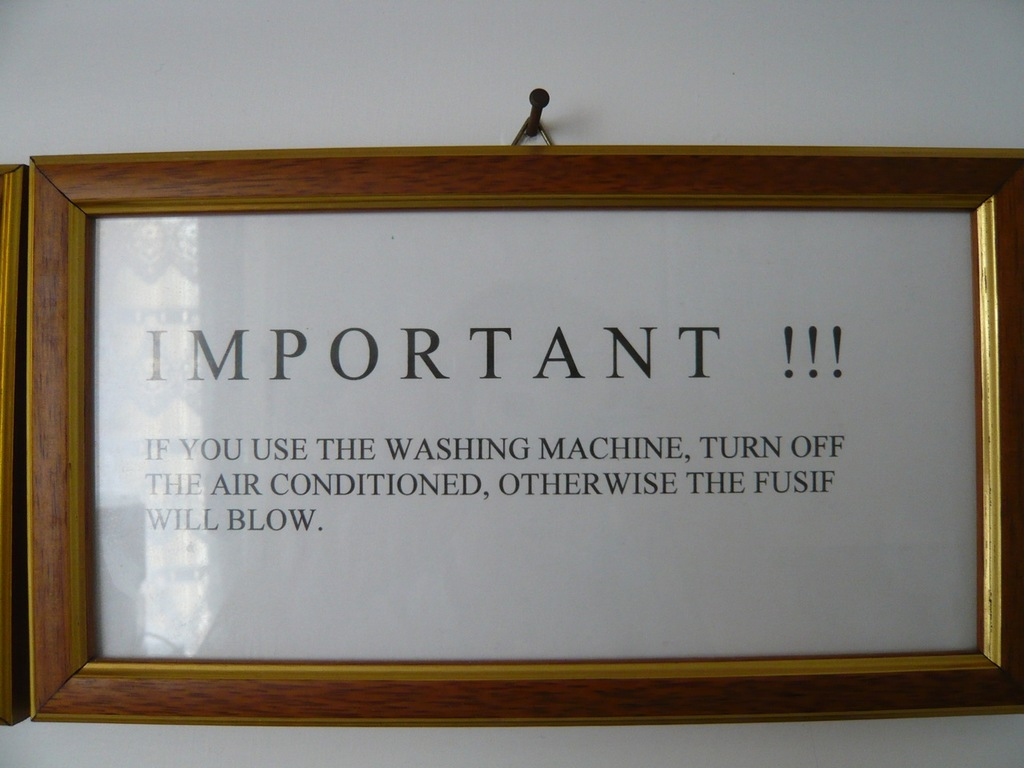What might be the consequences of ignoring the warning on this notice? Ignoring the warning could lead to several consequences, including tripping the electrical circuit, which might shut down power in parts of the building. Overloading the system consistently could also damage the electrical infrastructure, potentially leading to expensive repairs or even a fire hazard if not addressed promptly. 